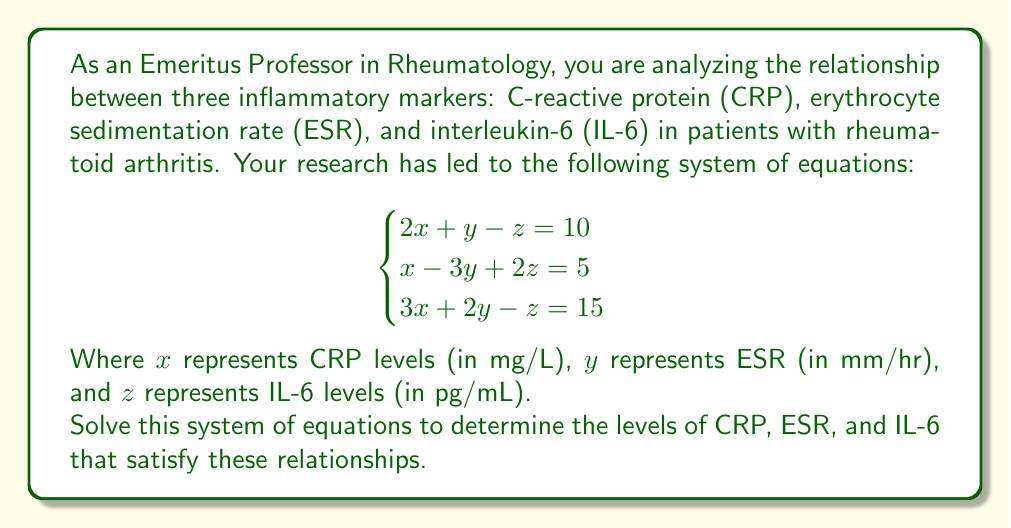Provide a solution to this math problem. To solve this system of equations, we'll use the elimination method:

1) First, let's eliminate $z$ by adding equations (1) and (2):

   $2x + y - z = 10$
   $x - 3y + 2z = 5$
   ----------------
   $3x - 2y + z = 15$ ... (4)

2) Now we have equation (3) and (4), both without $z$. Let's eliminate $y$ by adding these equations:

   $3x + 2y - z = 15$
   $3x - 2y + z = 15$
   ------------------
   $6x = 30$

3) Solving for $x$:
   $x = 5$

4) Now substitute $x = 5$ into equation (1):
   $2(5) + y - z = 10$
   $10 + y - z = 10$
   $y - z = 0$ ... (5)

5) Substitute $x = 5$ into equation (2):
   $5 - 3y + 2z = 5$
   $-3y + 2z = 0$
   $3y = 2z$
   $y = \frac{2z}{3}$ ... (6)

6) Substitute (6) into (5):
   $\frac{2z}{3} - z = 0$
   $\frac{2z}{3} - \frac{3z}{3} = 0$
   $-\frac{z}{3} = 0$
   $z = 0$

7) Now we can find $y$ by substituting $z = 0$ into (6):
   $y = \frac{2(0)}{3} = 0$

Therefore, the solution is $x = 5$, $y = 0$, and $z = 0$.
Answer: CRP (x) = 5 mg/L, ESR (y) = 0 mm/hr, IL-6 (z) = 0 pg/mL 